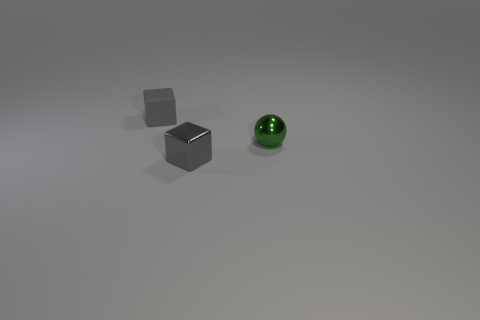There is a gray matte thing; is its shape the same as the tiny shiny object that is left of the green shiny sphere?
Provide a short and direct response. Yes. What number of other things are there of the same shape as the gray rubber thing?
Offer a terse response. 1. What number of things are either tiny objects or small blue shiny objects?
Give a very brief answer. 3. Is the tiny rubber cube the same color as the tiny metallic cube?
Keep it short and to the point. Yes. What is the shape of the gray thing that is to the left of the block in front of the tiny gray rubber thing?
Your answer should be compact. Cube. Is the number of small gray blocks less than the number of small green cylinders?
Offer a very short reply. No. Does the green metal object have the same size as the rubber block?
Your answer should be very brief. Yes. There is a small cube that is behind the gray metallic cube; is it the same color as the tiny shiny cube?
Offer a very short reply. Yes. What number of gray objects are in front of the gray shiny thing?
Offer a very short reply. 0. Are there more gray metallic objects than things?
Offer a terse response. No. 